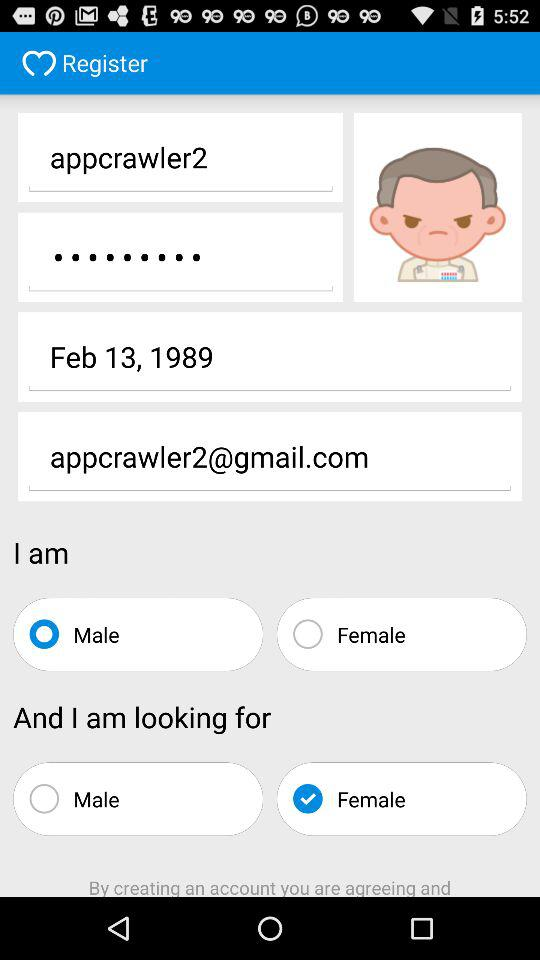What is the date of birth given on the screen? The given date of birth is February 13, 1989. 